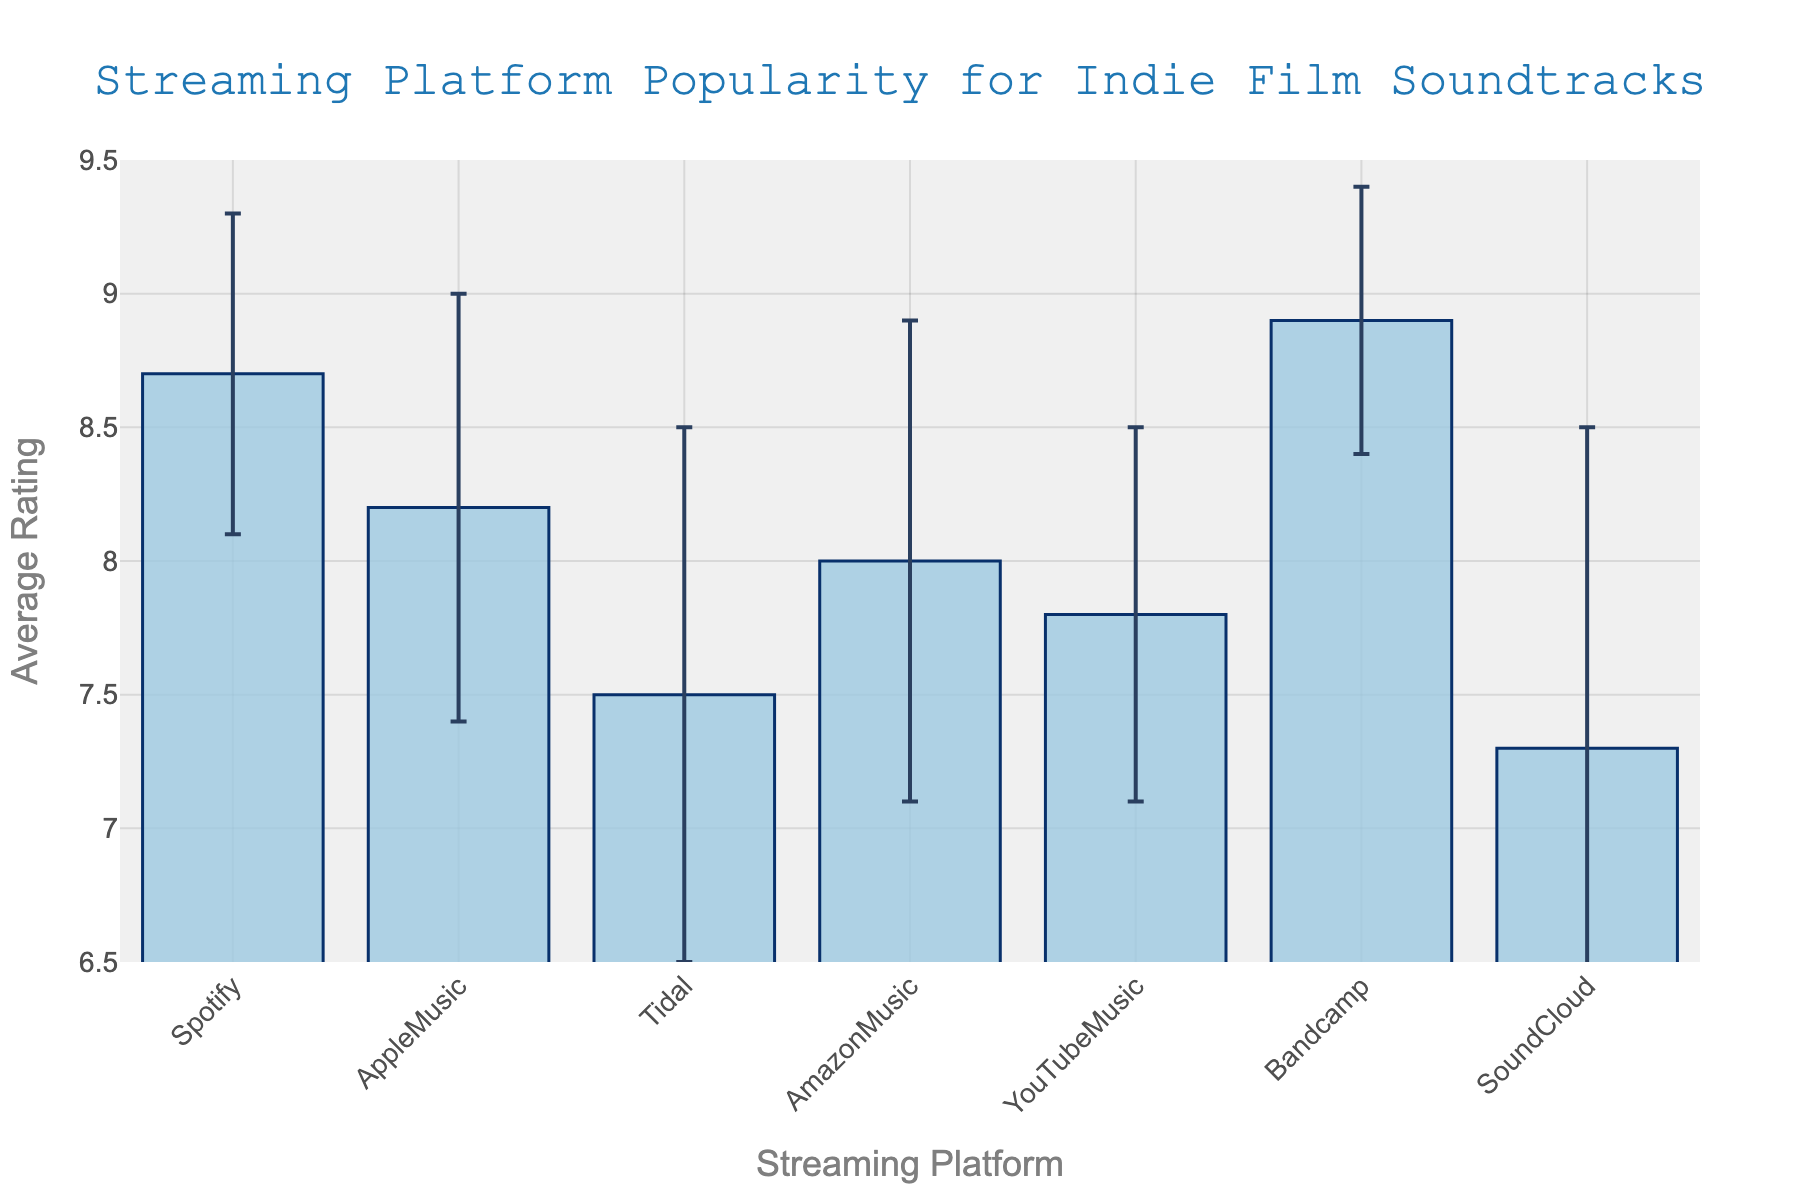What is the title of the figure? The title can be found at the top of the figure. It is usually in a larger and bold font, making it easy to identify.
Answer: Streaming Platform Popularity for Indie Film Soundtracks What is the highest average rating among the platforms? Identify the bar with the highest value on the y-axis. Compare all bars' heights to find the tallest one.
Answer: Bandcamp Which platform has the largest variability in user ratings? Look for the error bar with the greatest length, which represents the standard deviation.
Answer: SoundCloud What is the average rating for Spotify? Find the bar labeled 'Spotify' on the x-axis and check its height based on the y-axis scale.
Answer: 8.7 Which platform has a higher average rating, Tidal or YouTube Music? Compare the heights of the bars for Tidal and YouTube Music. The taller bar represents the higher average rating.
Answer: YouTube Music How does the average rating of Amazon Music compare to Apple Music? Compare the heights of the bars for Amazon Music and Apple Music. The taller bar indicates a higher average rating.
Answer: Amazon Music is lower What is the range of average ratings across all platforms? Identify the platform with the highest rating and the one with the lowest rating. Subtract the lowest value from the highest value.
Answer: 8.9 - 7.3 = 1.6 Which platform has the smallest variability in user ratings? Look for the smallest error bar, which indicates the least variability in ratings.
Answer: Bandcamp How many platforms have an average rating above 8.0? Count the number of bars that extend above the 8.0 value on the y-axis.
Answer: Four platforms What is the difference in average ratings between the highest and lowest-rated platforms? Subtract the average rating of the lowest-rated platform from the highest-rated platform.
Answer: 8.9 - 7.3 = 1.6 